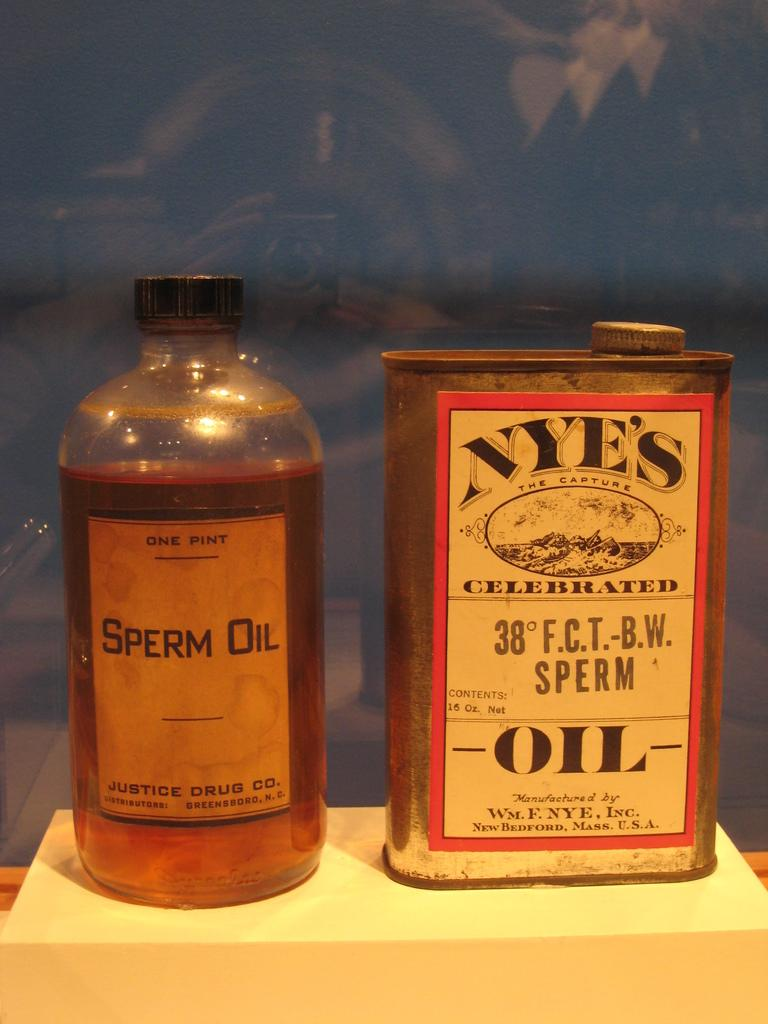<image>
Write a terse but informative summary of the picture. The bottle on the right has the words Sperm Oil written on it. 